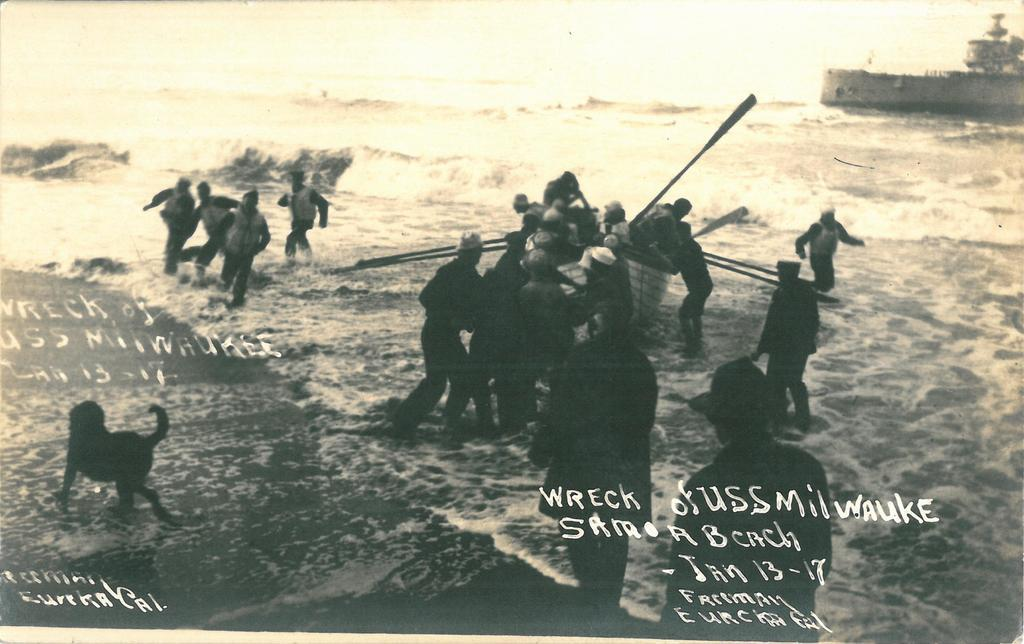What are the people in the image doing? There are people sitting in a boat and people standing in the image. What can be seen in the water? There is an animal in the image. What is the primary setting of the image? There is water visible in the image. What type of watch is the animal wearing in the image? There is no watch visible on the animal in the image. Can you describe the trail that the people are following in the image? There is no trail present in the image; it features people in a boat on water. 